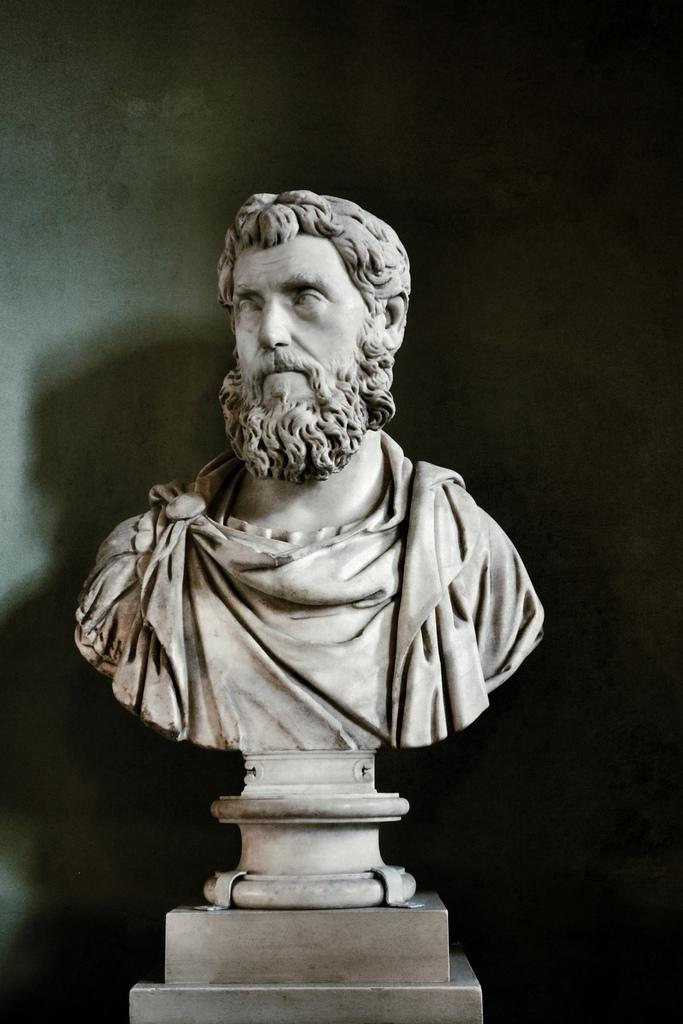What is the main subject of the image? There is a sculpture of a man in the image. What else can be seen in the image besides the sculpture? There is a wall in the image. What war is depicted in the image? There is no war depicted in the image; it features a sculpture of a man and a wall. What fact can be learned from the image? The image does not convey any specific fact; it simply shows a sculpture of a man and a wall. 